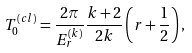Convert formula to latex. <formula><loc_0><loc_0><loc_500><loc_500>T _ { 0 } ^ { ( c l ) } = \frac { 2 \pi } { E _ { r } ^ { ( k ) } } \frac { k + 2 } { 2 k } \left ( r + \frac { 1 } { 2 } \right ) ,</formula> 